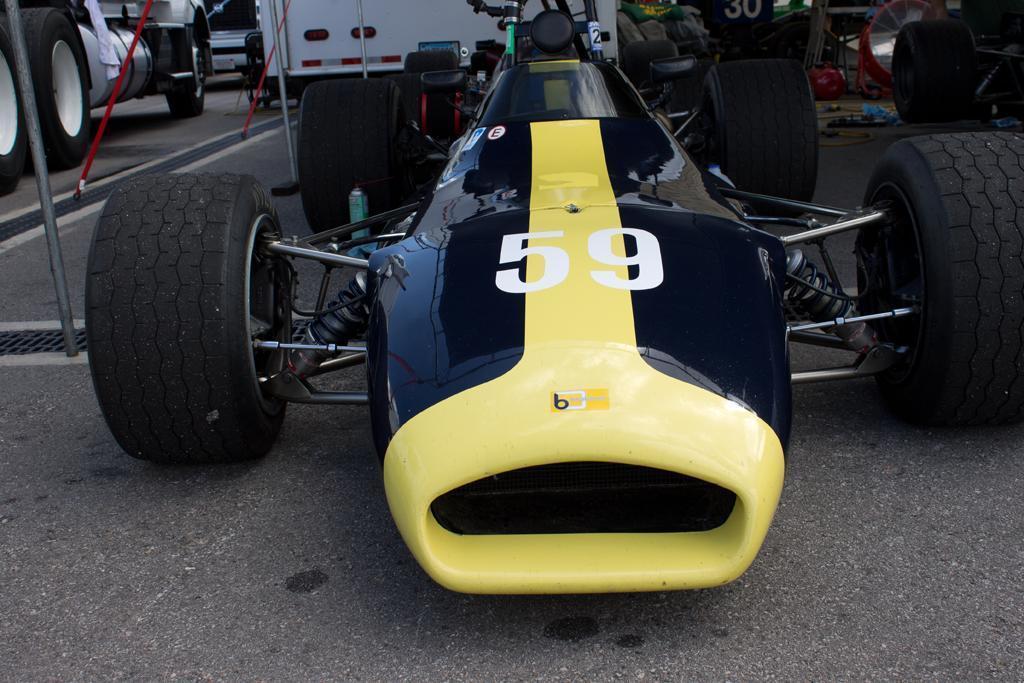Describe this image in one or two sentences. In front of the picture, we see the sports car in black and yellow color. Behind that, we see a vehicle in white color. On the left side, we see the vehicles. On the right side, we see the vehicles and a board in green and blue color. Beside the vehicles, we see some objects in blue and red color. At the bottom, we see the road. 